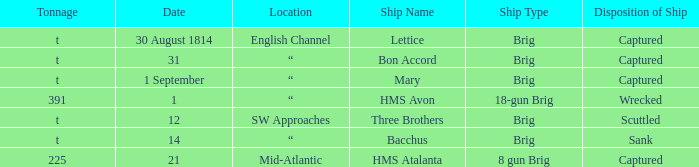What date was a brig type ship located in SW Approaches? 12.0. 